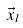Convert formula to latex. <formula><loc_0><loc_0><loc_500><loc_500>\vec { x } _ { l }</formula> 